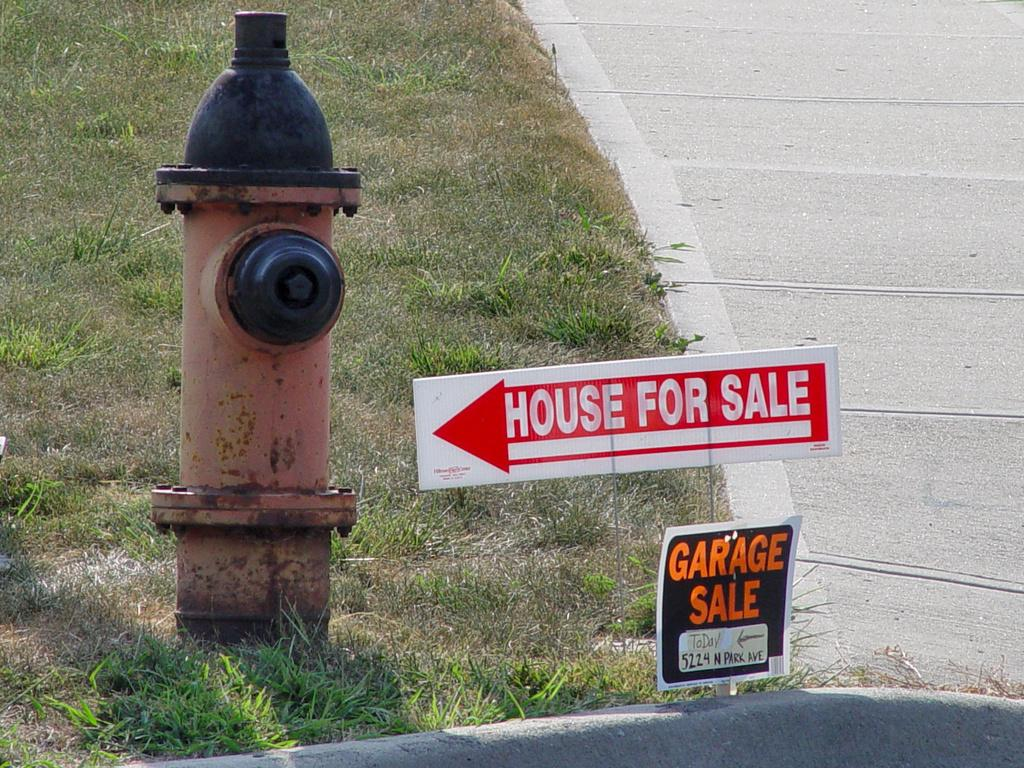What object can be seen in the picture that is used for fire safety? There is a fire hydrant in the picture. What type of vegetation is present in the picture? There is grass in the picture. What material is visible in the picture that is used for construction or signage? There are boards in the picture. What can be found on the boards that provides information or instructions? There is writing on the boards. How many chickens are standing on the fire hydrant in the picture? There are no chickens present in the image. What type of fruit can be seen growing in the garden in the picture? There is no garden present in the image. 